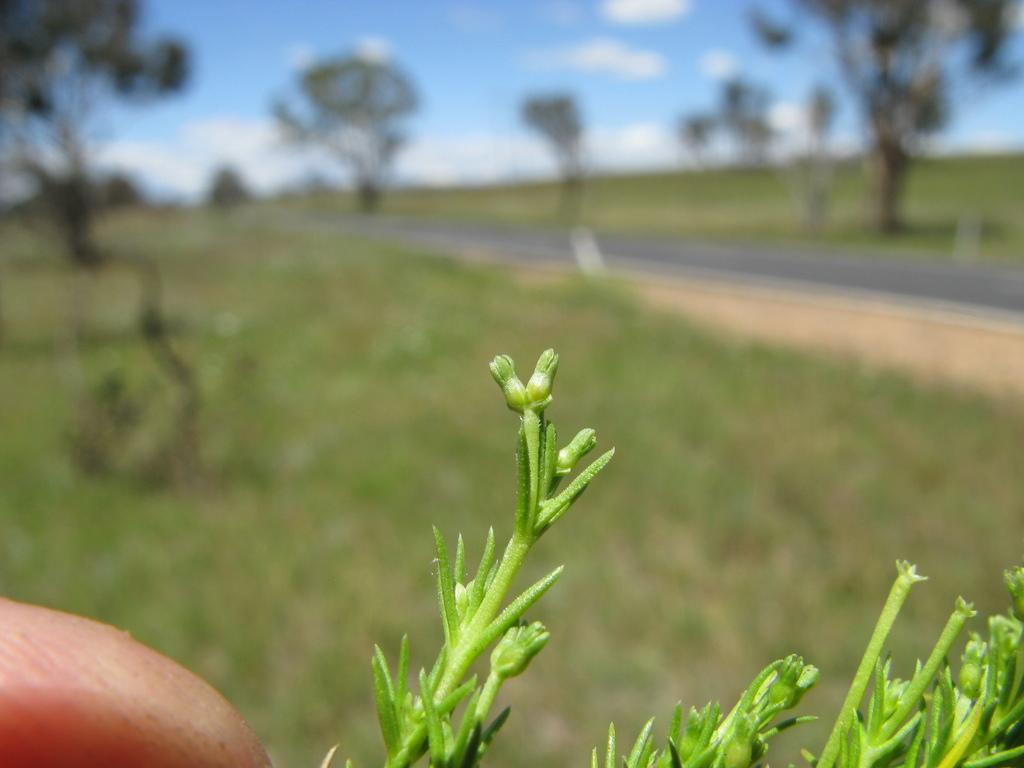What is the main subject in the center of the image? There is a plant in the center of the image. What part of a human body is present in the image? A human finger is present in the image. What can be seen in the background of the image? There is a road, grass, trees, and the sky visible in the background of the image. What is the condition of the sky in the image? Clouds are present in the sky. What type of stone can be heard in the image? There is no stone present in the image, and therefore no sound can be heard from it. What flavor of ice cream is being eaten by the person in the image? There is no person or ice cream present in the image, so it is impossible to determine the flavor being eaten. 